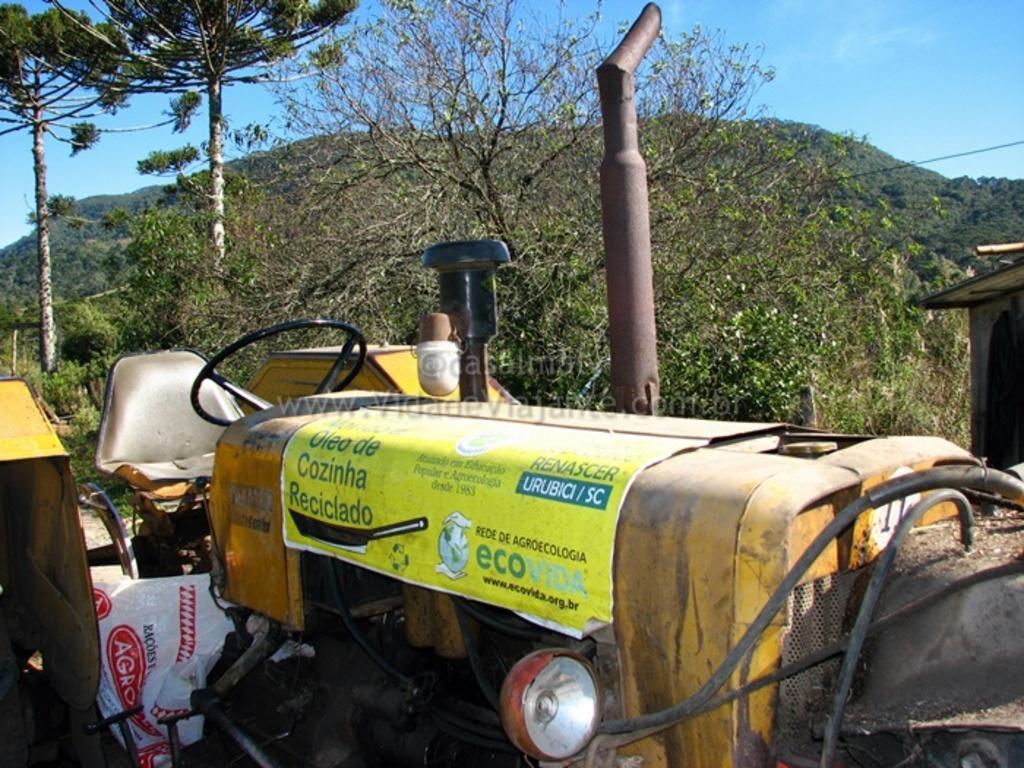Could you give a brief overview of what you see in this image? There is a tractor at the bottom of this image. We can see trees and a mountain in the background and the sky is at the top of this image. 